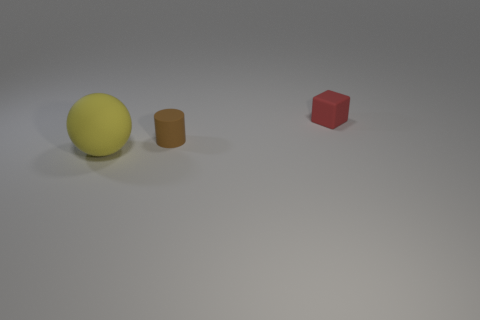If you had to guess, what material is the floor made of? The floor has a uniform, matte appearance with a slight texture that could suggest a synthetic material designed for photography or rendering purposes; it's not indicative of any specific real-world material but rather designed to enhance the visibility of objects placed on it. 